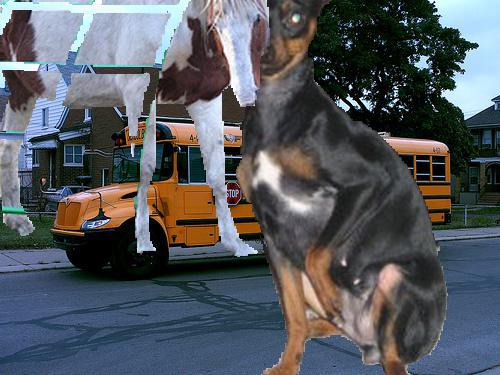Would there be a bus in the image after the bus disappeared from this picture? No 